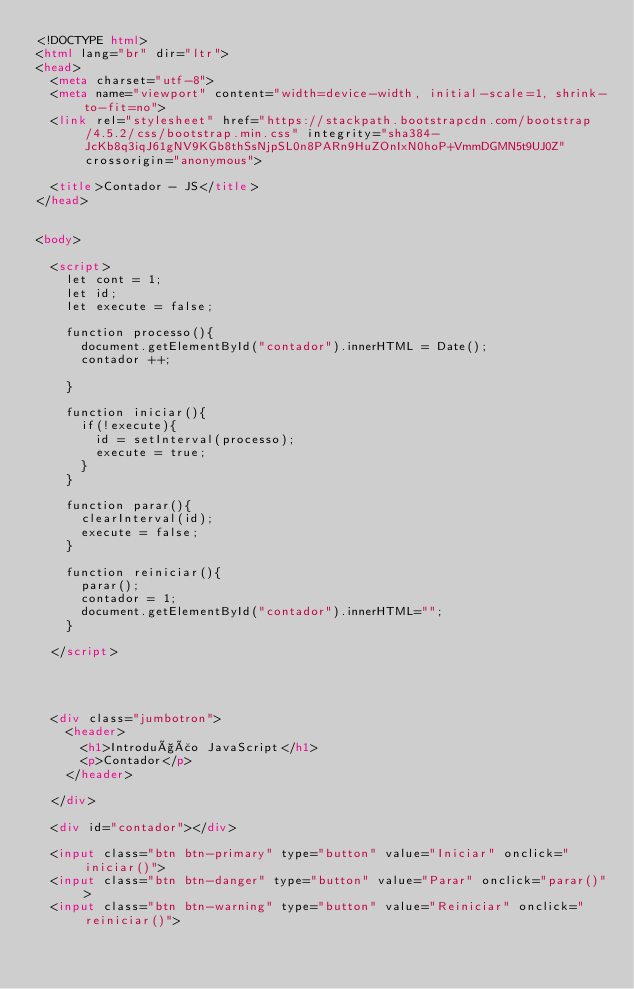<code> <loc_0><loc_0><loc_500><loc_500><_HTML_><!DOCTYPE html>
<html lang="br" dir="ltr">
<head>
  <meta charset="utf-8">
  <meta name="viewport" content="width=device-width, initial-scale=1, shrink-to-fit=no">
  <link rel="stylesheet" href="https://stackpath.bootstrapcdn.com/bootstrap/4.5.2/css/bootstrap.min.css" integrity="sha384-JcKb8q3iqJ61gNV9KGb8thSsNjpSL0n8PARn9HuZOnIxN0hoP+VmmDGMN5t9UJ0Z" crossorigin="anonymous">

  <title>Contador - JS</title>
</head>


<body>

  <script>
    let cont = 1;
    let id;
    let execute = false;

    function processo(){
      document.getElementById("contador").innerHTML = Date();
      contador ++;

    }

    function iniciar(){
      if(!execute){
        id = setInterval(processo);
        execute = true;
      }
    }

    function parar(){
      clearInterval(id);
      execute = false;
    }

    function reiniciar(){
      parar();
      contador = 1;
      document.getElementById("contador").innerHTML="";
    }

  </script>




  <div class="jumbotron">
    <header>
      <h1>Introdução JavaScript</h1>
      <p>Contador</p>
    </header>

  </div>

  <div id="contador"></div>

  <input class="btn btn-primary" type="button" value="Iniciar" onclick="iniciar()">
  <input class="btn btn-danger" type="button" value="Parar" onclick="parar()">
  <input class="btn btn-warning" type="button" value="Reiniciar" onclick="reiniciar()">
</code> 